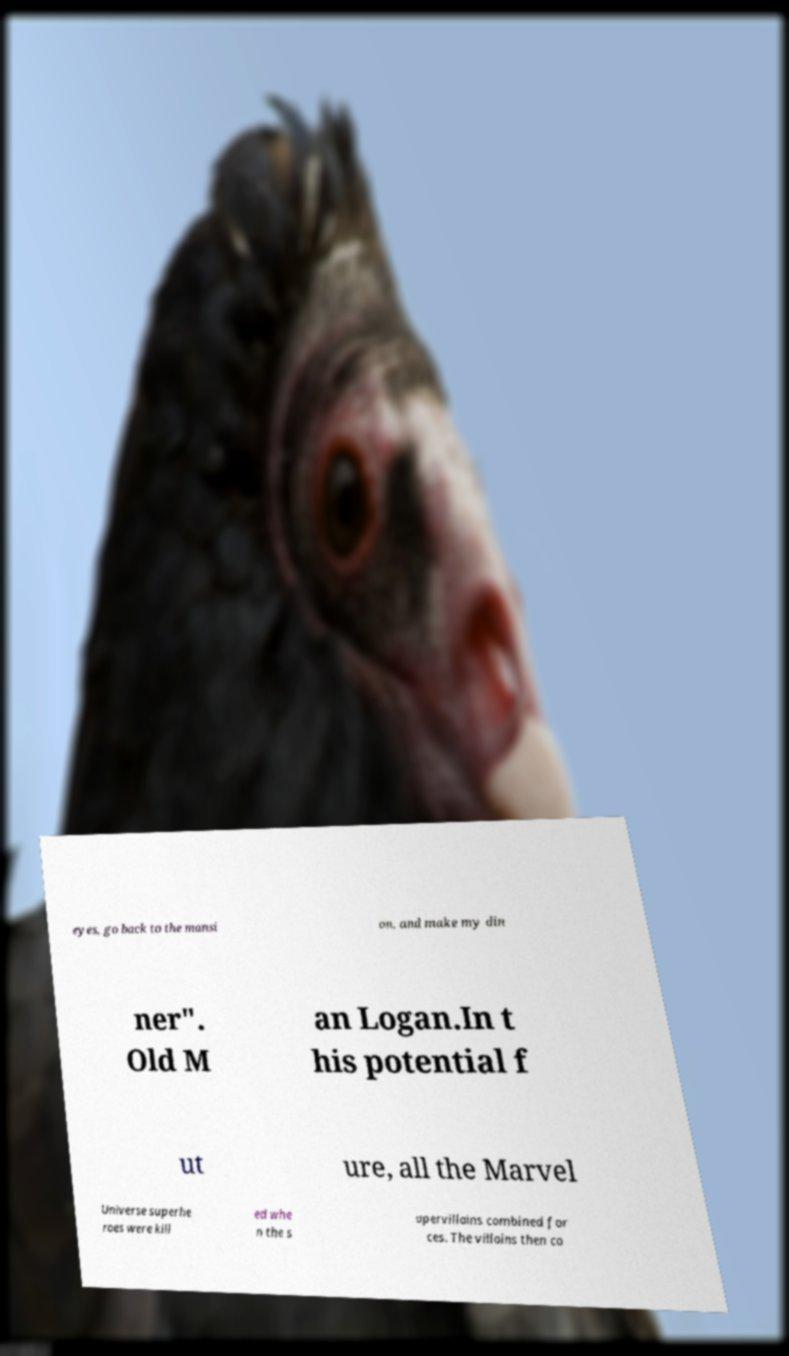Please identify and transcribe the text found in this image. eyes, go back to the mansi on, and make my din ner". Old M an Logan.In t his potential f ut ure, all the Marvel Universe superhe roes were kill ed whe n the s upervillains combined for ces. The villains then co 